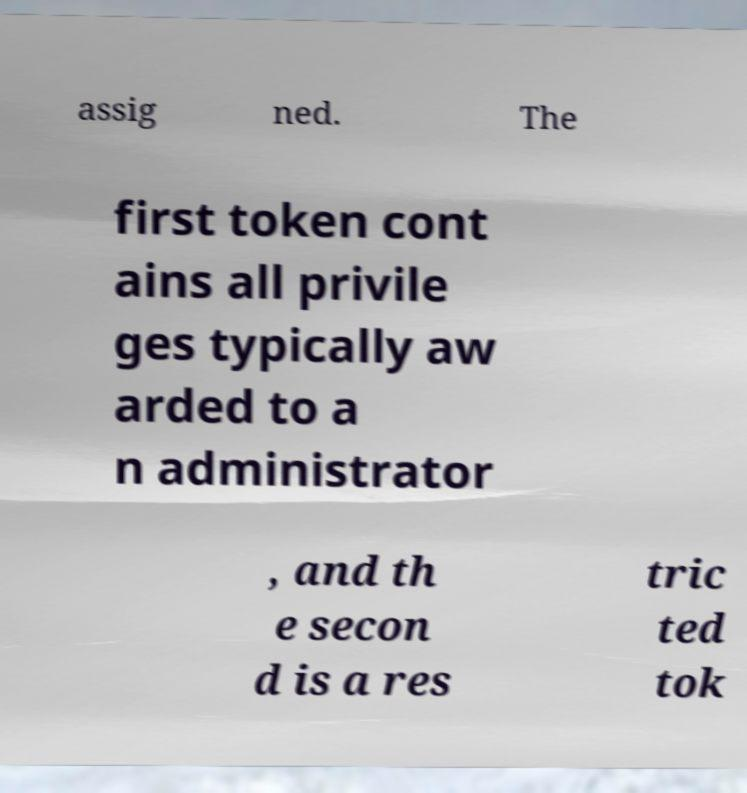What messages or text are displayed in this image? I need them in a readable, typed format. assig ned. The first token cont ains all privile ges typically aw arded to a n administrator , and th e secon d is a res tric ted tok 